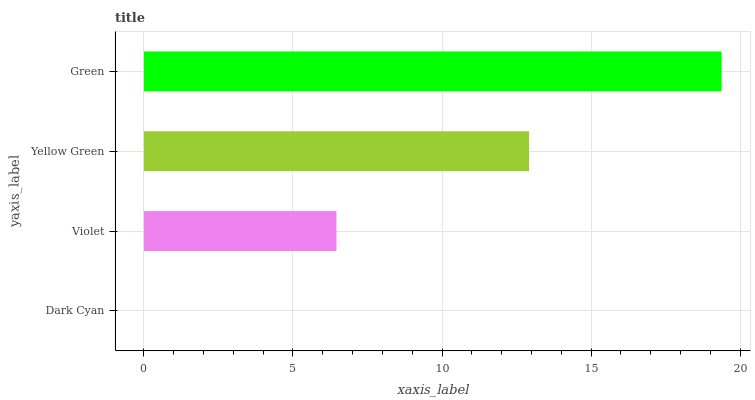Is Dark Cyan the minimum?
Answer yes or no. Yes. Is Green the maximum?
Answer yes or no. Yes. Is Violet the minimum?
Answer yes or no. No. Is Violet the maximum?
Answer yes or no. No. Is Violet greater than Dark Cyan?
Answer yes or no. Yes. Is Dark Cyan less than Violet?
Answer yes or no. Yes. Is Dark Cyan greater than Violet?
Answer yes or no. No. Is Violet less than Dark Cyan?
Answer yes or no. No. Is Yellow Green the high median?
Answer yes or no. Yes. Is Violet the low median?
Answer yes or no. Yes. Is Dark Cyan the high median?
Answer yes or no. No. Is Green the low median?
Answer yes or no. No. 